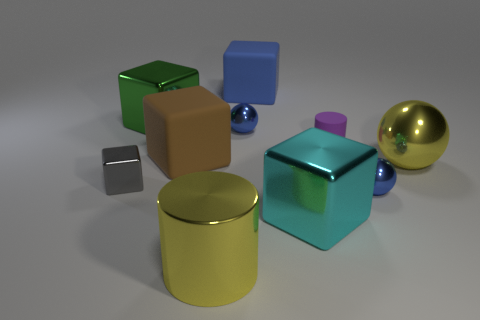The shiny cylinder has what color?
Make the answer very short. Yellow. Does the yellow shiny object right of the large blue block have the same size as the blue metallic object that is in front of the big sphere?
Make the answer very short. No. Is the number of purple rubber objects less than the number of yellow metallic blocks?
Your answer should be very brief. No. There is a big blue cube; how many large cubes are in front of it?
Ensure brevity in your answer.  3. What is the purple cylinder made of?
Give a very brief answer. Rubber. Do the big shiny cylinder and the big metal ball have the same color?
Ensure brevity in your answer.  Yes. Are there fewer metallic cylinders that are right of the purple object than brown matte cubes?
Your answer should be compact. Yes. The metallic cube that is in front of the gray metal cube is what color?
Provide a succinct answer. Cyan. What shape is the tiny gray thing?
Keep it short and to the point. Cube. Are there any large objects left of the thing that is right of the tiny blue ball that is right of the cyan metal block?
Offer a very short reply. Yes. 